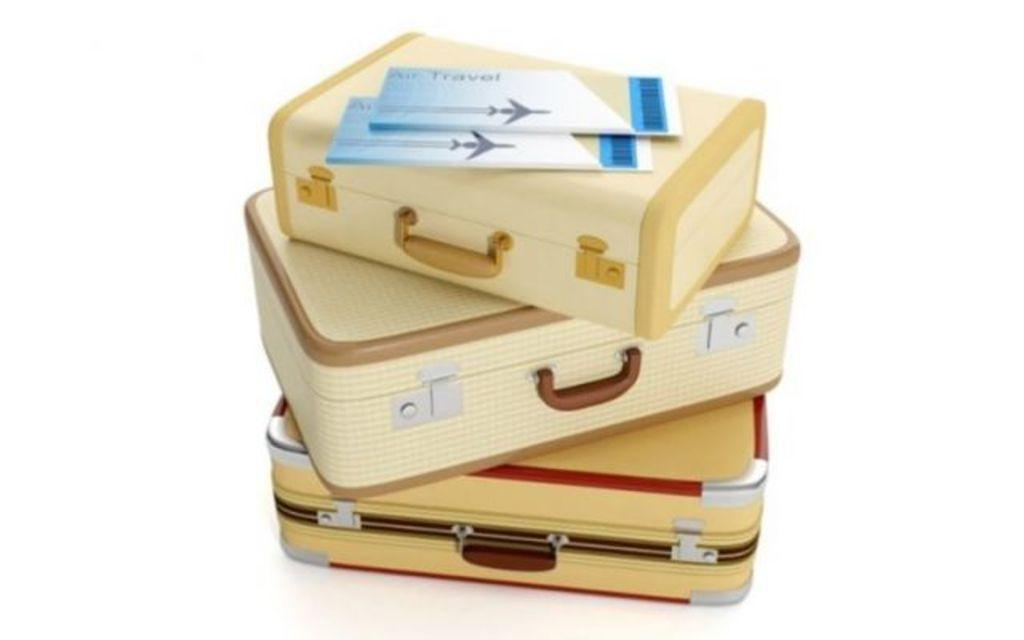How many suitcases are visible in the image? There are three suitcases in the picture. How are the suitcases arranged in the image? The suitcases are placed one above the other. What type of books can be seen on the side of the suitcases in the image? There are no books visible in the image; it only features three suitcases placed one above the other. 